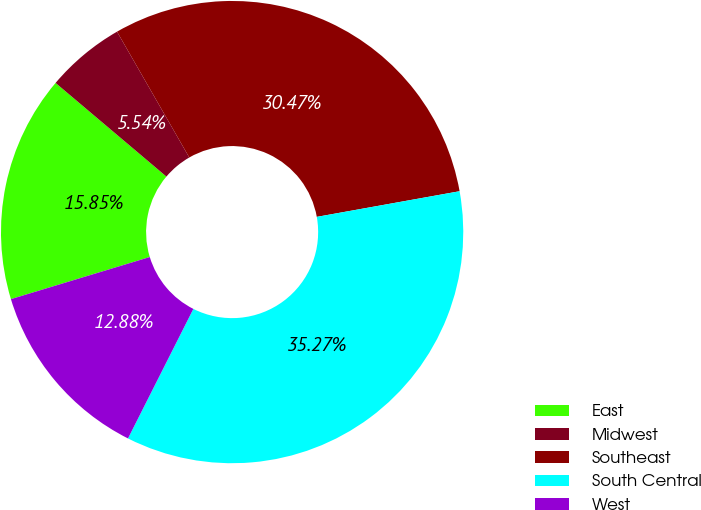Convert chart. <chart><loc_0><loc_0><loc_500><loc_500><pie_chart><fcel>East<fcel>Midwest<fcel>Southeast<fcel>South Central<fcel>West<nl><fcel>15.85%<fcel>5.54%<fcel>30.47%<fcel>35.27%<fcel>12.88%<nl></chart> 